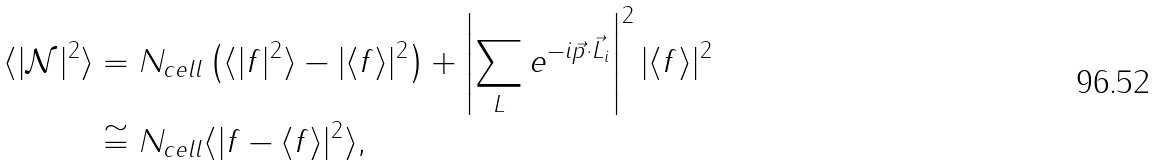Convert formula to latex. <formula><loc_0><loc_0><loc_500><loc_500>\langle | \mathcal { N } | ^ { 2 } \rangle & = N _ { c e l l } \left ( \langle | f | ^ { 2 } \rangle - | \langle f \rangle | ^ { 2 } \right ) + \left | \sum _ { L } e ^ { - i \vec { p } \cdot \vec { L } _ { i } } \right | ^ { 2 } | \langle f \rangle | ^ { 2 } \\ & \cong N _ { c e l l } \langle | f - \langle f \rangle | ^ { 2 } \rangle ,</formula> 